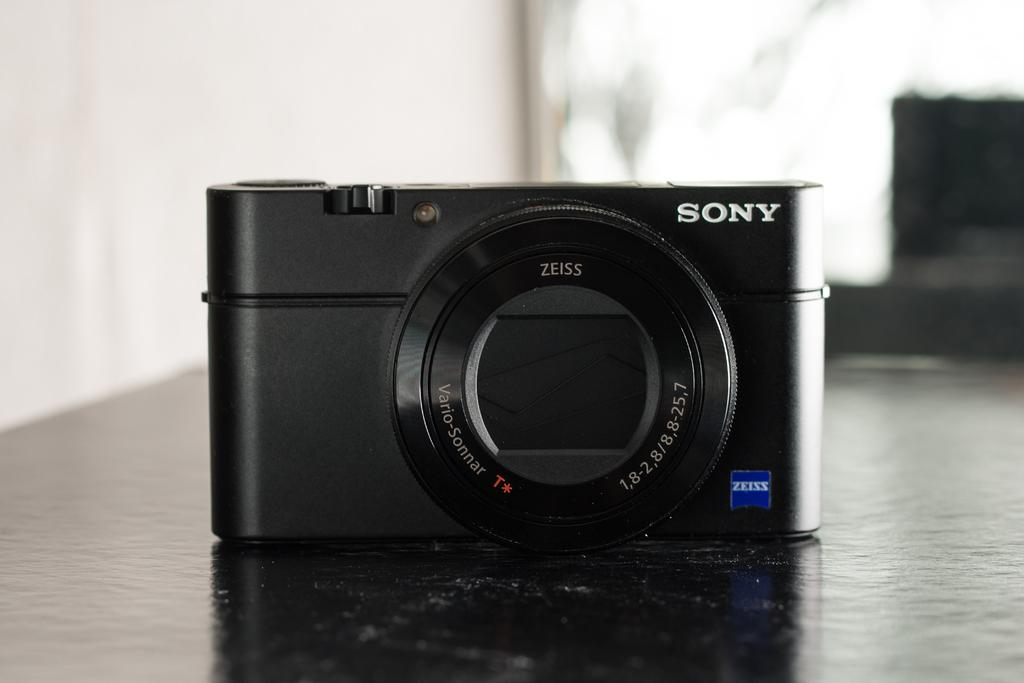<image>
Summarize the visual content of the image. A sony camera is sitting on the table. 